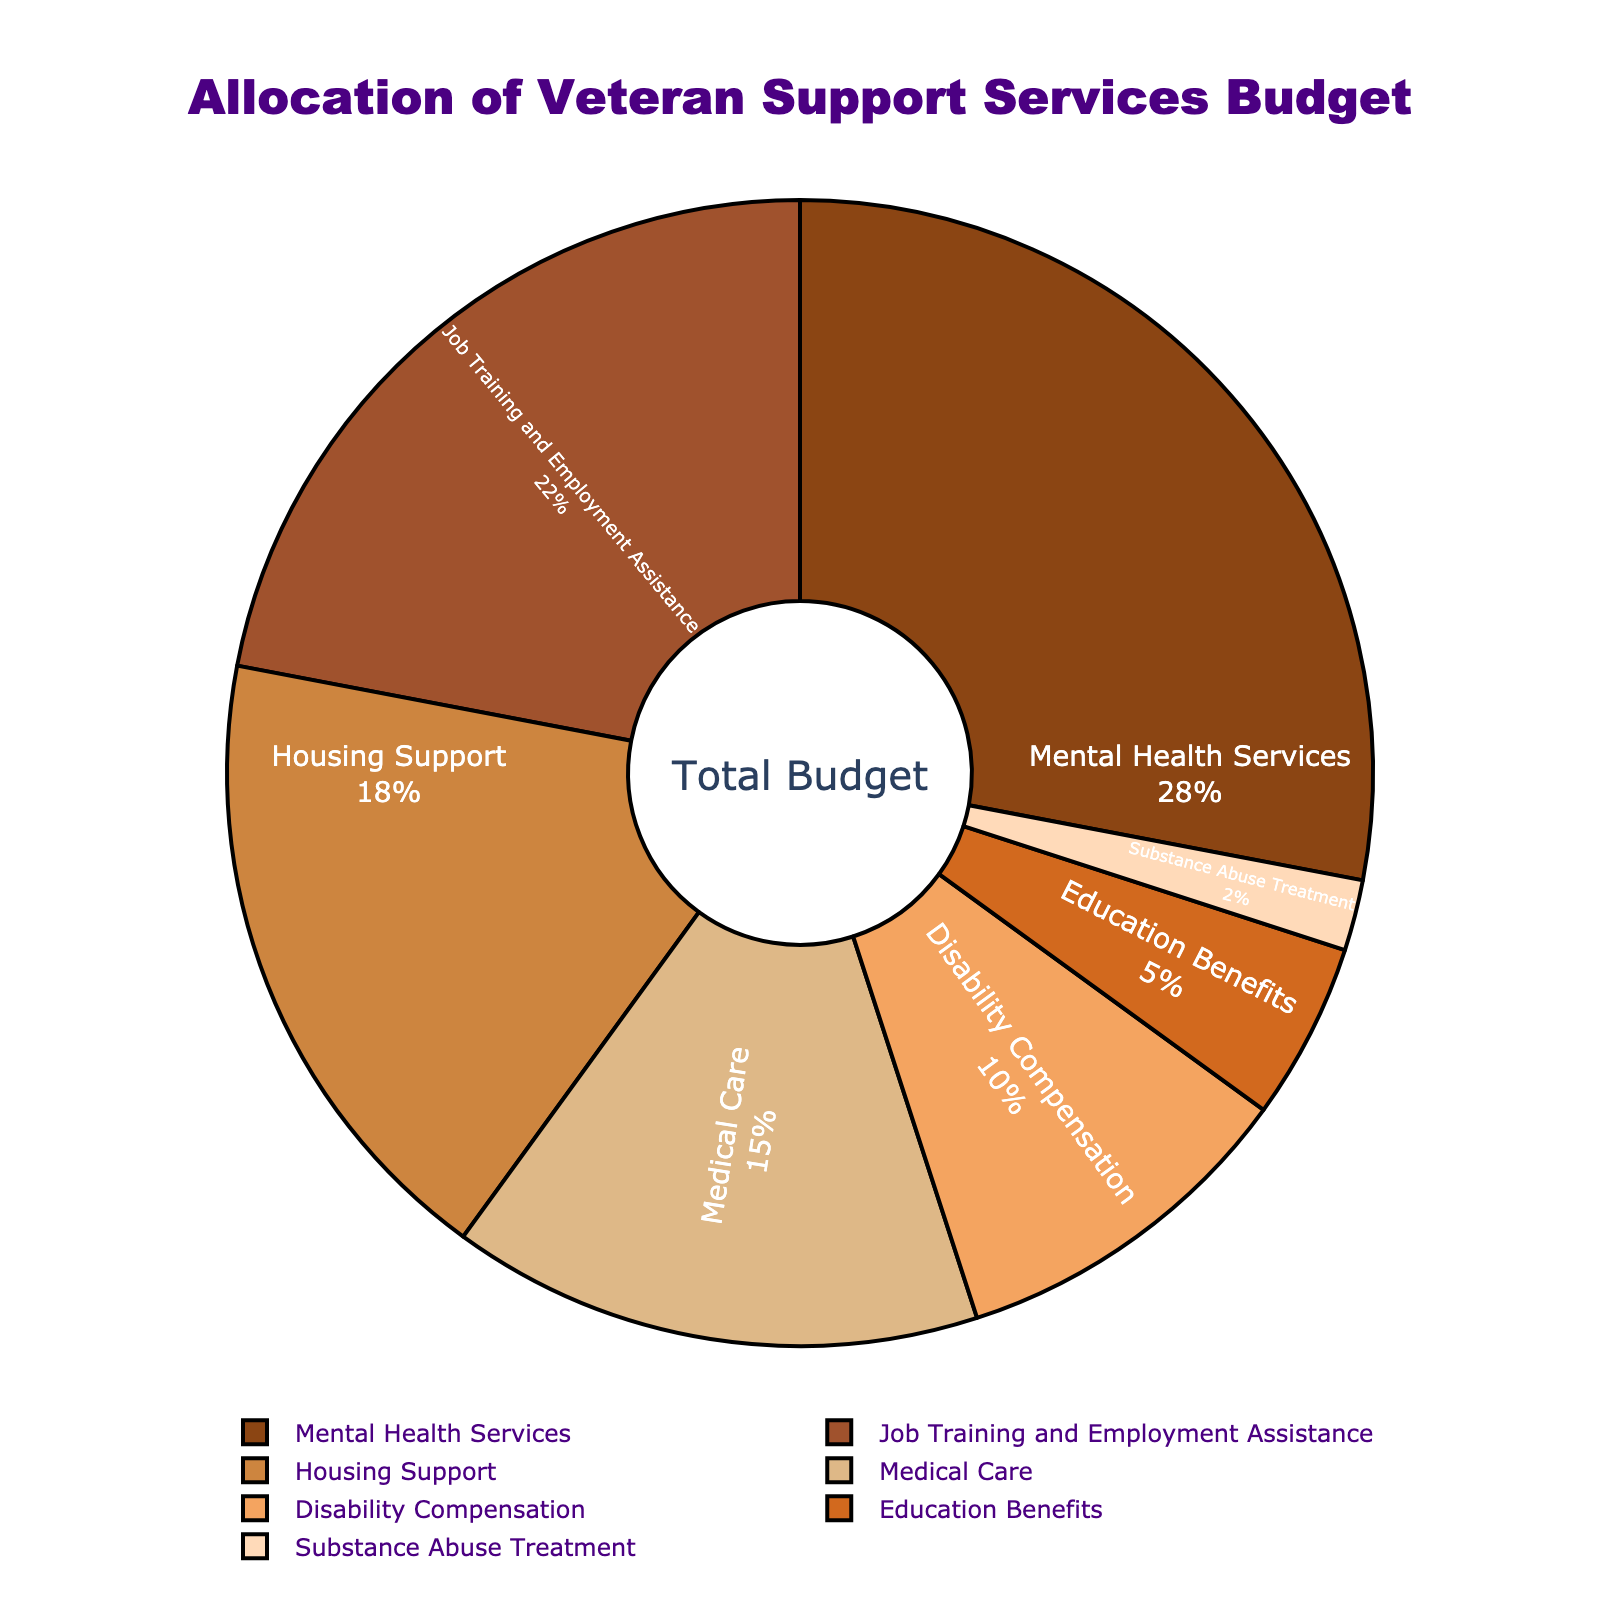What is the largest allocation category in the veteran support services budget? To find the largest allocation category, look at the segment of the pie chart with the largest percentage. This segment represents the category with the highest budget allocation.
Answer: Mental Health Services Which category has a higher budget allocation: Job Training and Employment Assistance or Housing Support? Compare the percentages of the budget allocated to Job Training and Employment Assistance and Housing Support to determine which is higher.
Answer: Job Training and Employment Assistance What is the combined budget allocation percentage for Medical Care and Disability Compensation? Add the percentages for Medical Care (15%) and Disability Compensation (10%) to find the combined allocation. 15% + 10% = 25%
Answer: 25% How much more budget allocation does Mental Health Services receive compared to Education Benefits? Subtract the percentage allocated to Education Benefits from the percentage allocated to Mental Health Services: 28% - 5% = 23%
Answer: 23% Between Substance Abuse Treatment and Housing Support, which category receives less funding, and by how much? Determine which category has the smaller percentage and subtract that percentage from the larger one: 18% - 2% = 16%
Answer: Substance Abuse Treatment, 16% If you combine the percentages of the three smallest budget categories, what is their total? Add the percentages for the three smallest categories: Education Benefits (5%), Substance Abuse Treatment (2%), and Disability Compensation (10%). 5% + 2% + 10% = 17%
Answer: 17% Identify the two categories with the closest budget allocations and state their percentages. Look at the percentages of all categories and find the two that are closest in value. Job Training and Employment Assistance (22%) and Housing Support (18%) are closest with a 4% difference.
Answer: Job Training and Employment Assistance: 22%, Housing Support: 18% What percentage of the budget is allocated to services related to mental health and substance abuse combined? Add the percentages for Mental Health Services and Substance Abuse Treatment: 28% + 2% = 30%.
Answer: 30% By how much does the allocation for Job Training and Employment Assistance exceed the combined allocation for Disability Compensation and Substance Abuse Treatment? Combine the percentages for Disability Compensation and Substance Abuse Treatment, then subtract this total from the percentage for Job Training and Employment Assistance: 10% + 2% = 12%; 22% - 12% = 10%
Answer: 10% What is the difference in budget allocation between the two largest categories? Subtract the percentage allocated to Job Training and Employment Assistance from the percentage allocated to Mental Health Services: 28% - 22% = 6%
Answer: 6% 